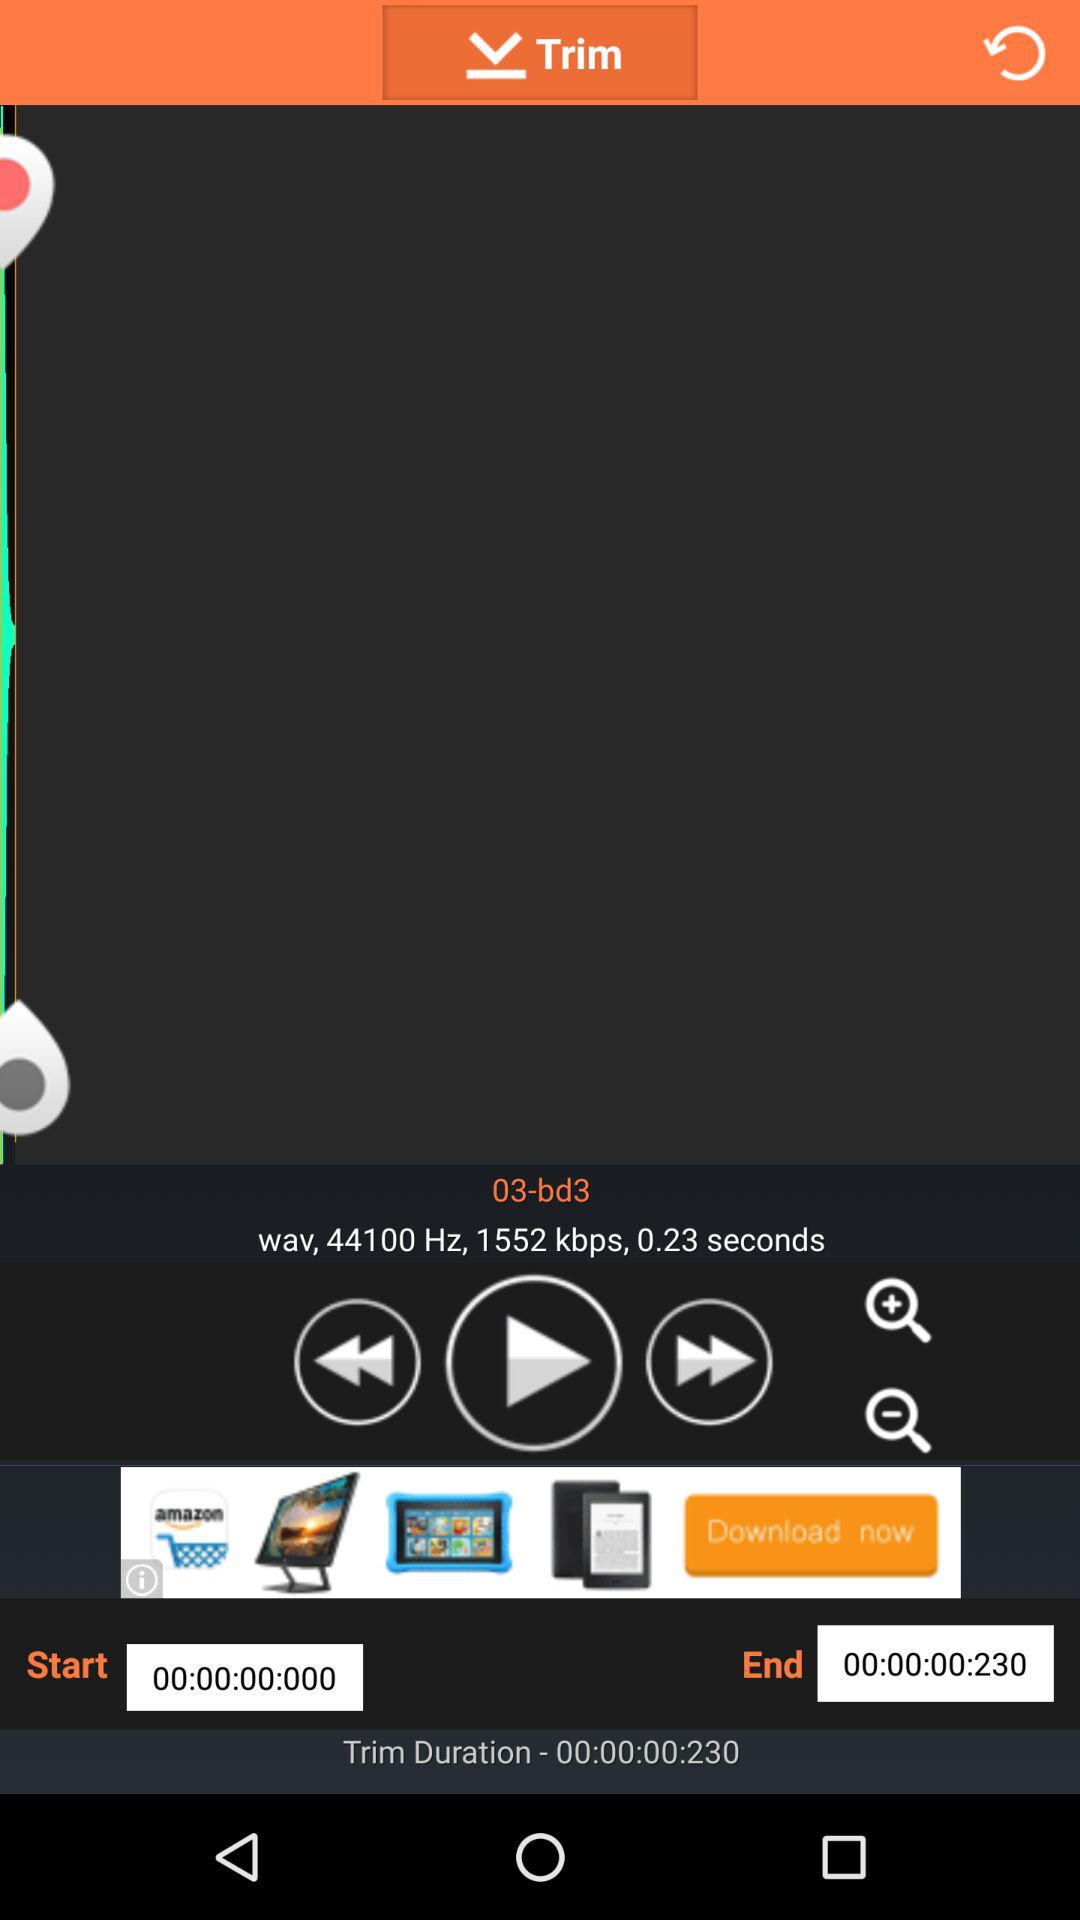What's the bitrate? The bitrate is 1552 kbps. 